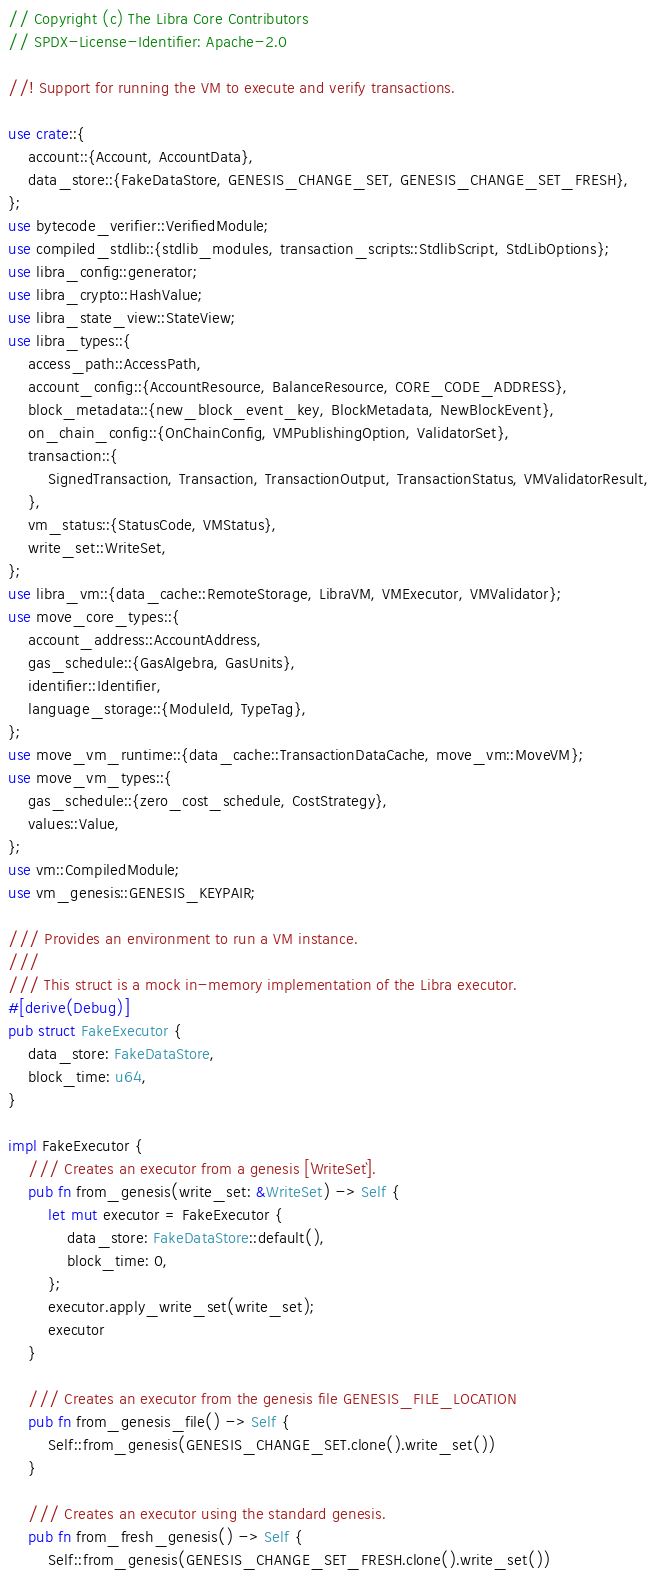Convert code to text. <code><loc_0><loc_0><loc_500><loc_500><_Rust_>// Copyright (c) The Libra Core Contributors
// SPDX-License-Identifier: Apache-2.0

//! Support for running the VM to execute and verify transactions.

use crate::{
    account::{Account, AccountData},
    data_store::{FakeDataStore, GENESIS_CHANGE_SET, GENESIS_CHANGE_SET_FRESH},
};
use bytecode_verifier::VerifiedModule;
use compiled_stdlib::{stdlib_modules, transaction_scripts::StdlibScript, StdLibOptions};
use libra_config::generator;
use libra_crypto::HashValue;
use libra_state_view::StateView;
use libra_types::{
    access_path::AccessPath,
    account_config::{AccountResource, BalanceResource, CORE_CODE_ADDRESS},
    block_metadata::{new_block_event_key, BlockMetadata, NewBlockEvent},
    on_chain_config::{OnChainConfig, VMPublishingOption, ValidatorSet},
    transaction::{
        SignedTransaction, Transaction, TransactionOutput, TransactionStatus, VMValidatorResult,
    },
    vm_status::{StatusCode, VMStatus},
    write_set::WriteSet,
};
use libra_vm::{data_cache::RemoteStorage, LibraVM, VMExecutor, VMValidator};
use move_core_types::{
    account_address::AccountAddress,
    gas_schedule::{GasAlgebra, GasUnits},
    identifier::Identifier,
    language_storage::{ModuleId, TypeTag},
};
use move_vm_runtime::{data_cache::TransactionDataCache, move_vm::MoveVM};
use move_vm_types::{
    gas_schedule::{zero_cost_schedule, CostStrategy},
    values::Value,
};
use vm::CompiledModule;
use vm_genesis::GENESIS_KEYPAIR;

/// Provides an environment to run a VM instance.
///
/// This struct is a mock in-memory implementation of the Libra executor.
#[derive(Debug)]
pub struct FakeExecutor {
    data_store: FakeDataStore,
    block_time: u64,
}

impl FakeExecutor {
    /// Creates an executor from a genesis [`WriteSet`].
    pub fn from_genesis(write_set: &WriteSet) -> Self {
        let mut executor = FakeExecutor {
            data_store: FakeDataStore::default(),
            block_time: 0,
        };
        executor.apply_write_set(write_set);
        executor
    }

    /// Creates an executor from the genesis file GENESIS_FILE_LOCATION
    pub fn from_genesis_file() -> Self {
        Self::from_genesis(GENESIS_CHANGE_SET.clone().write_set())
    }

    /// Creates an executor using the standard genesis.
    pub fn from_fresh_genesis() -> Self {
        Self::from_genesis(GENESIS_CHANGE_SET_FRESH.clone().write_set())</code> 